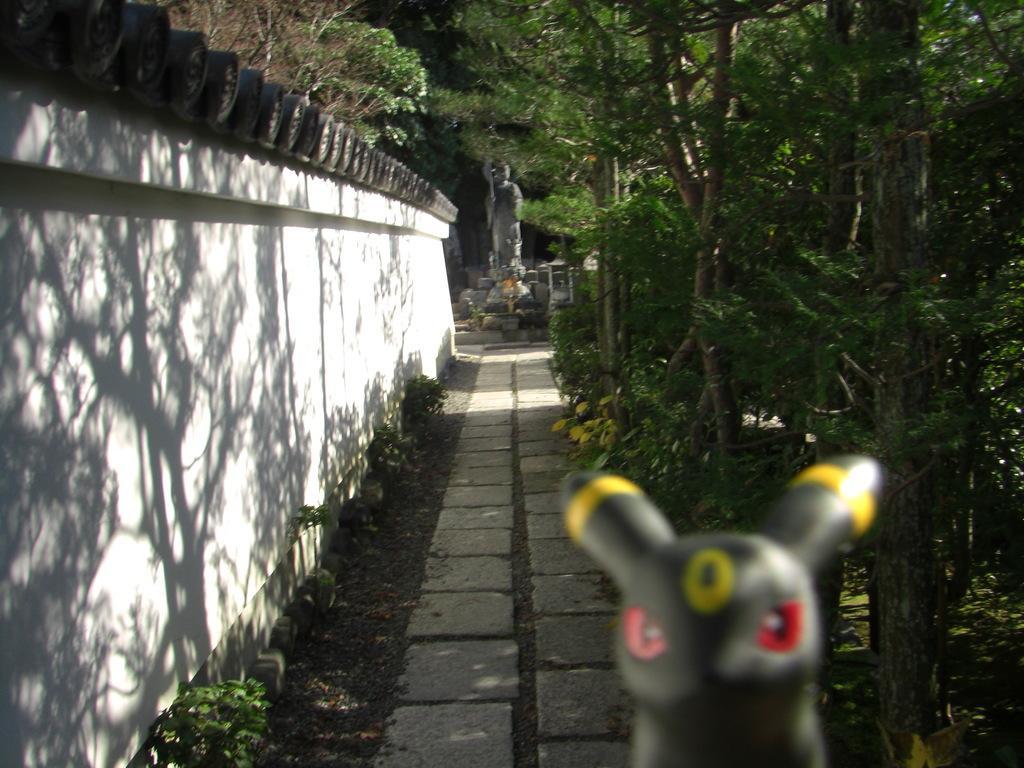Can you describe this image briefly? In this image at the bottom we can see a toy. In the background we can see a statue, trees, plants and wall on the left side. 